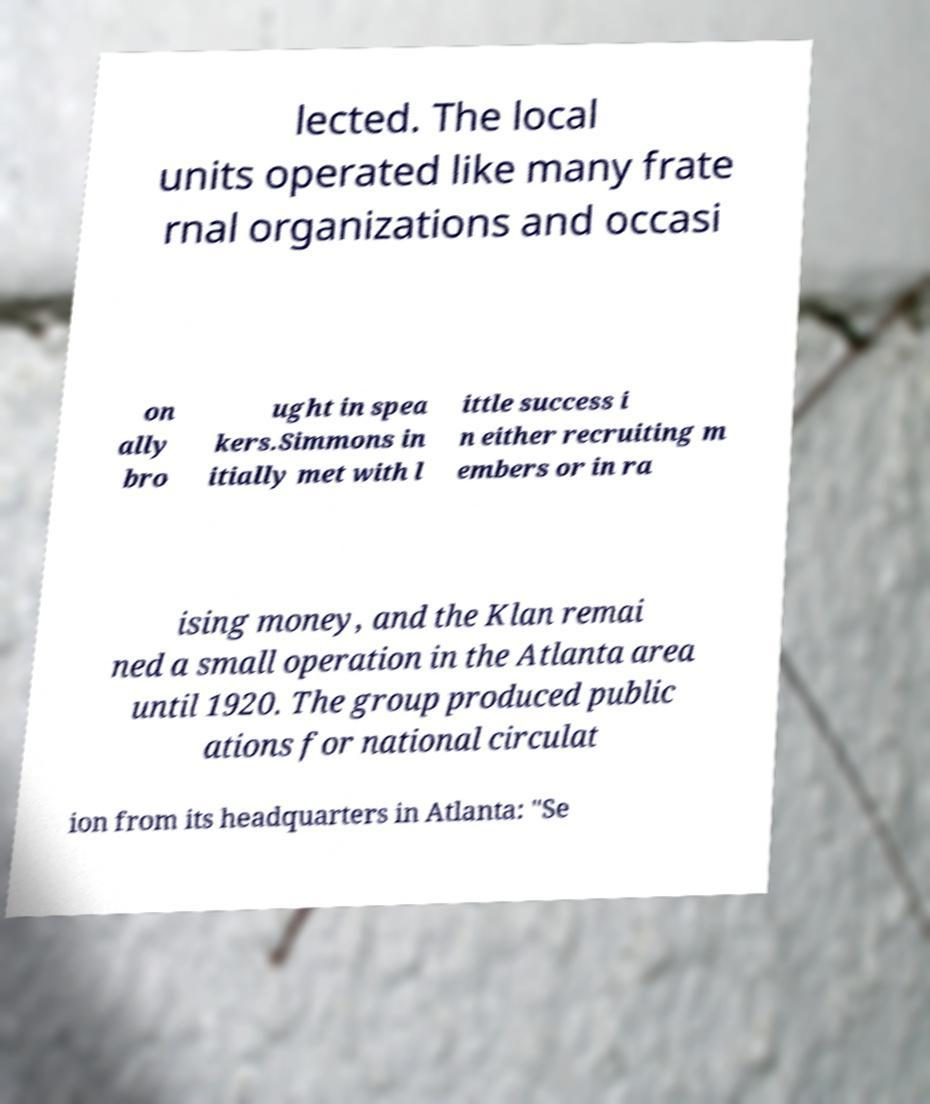Could you extract and type out the text from this image? lected. The local units operated like many frate rnal organizations and occasi on ally bro ught in spea kers.Simmons in itially met with l ittle success i n either recruiting m embers or in ra ising money, and the Klan remai ned a small operation in the Atlanta area until 1920. The group produced public ations for national circulat ion from its headquarters in Atlanta: "Se 